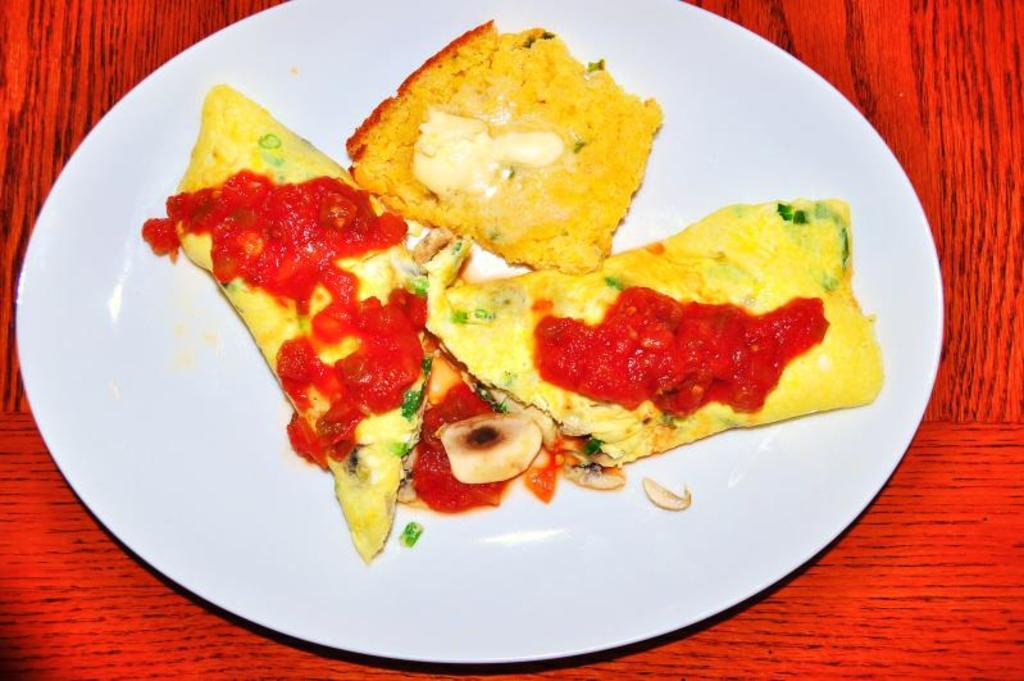What color is the plate in the image? The plate in the image is white colored. What is the plate placed on? The plate is on a red and black colored object. What can be seen on top of the plate? There is a food item on the plate. What colors are present in the food item? The food item has yellow, green, red, and cream colors. Is there a stream of water flowing through the plate in the image? No, there is no stream of water flowing through the plate in the image. 